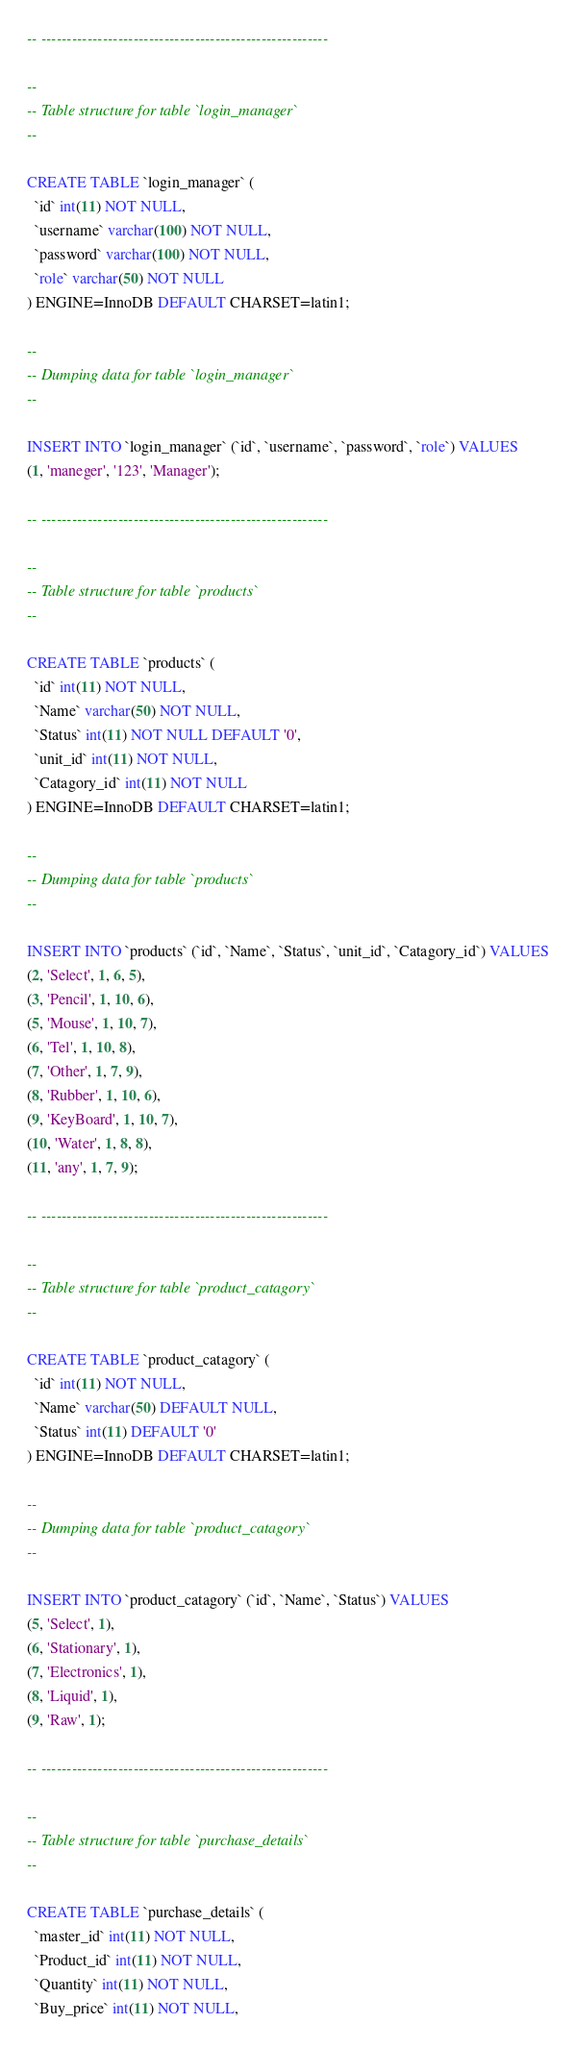<code> <loc_0><loc_0><loc_500><loc_500><_SQL_>-- --------------------------------------------------------

--
-- Table structure for table `login_manager`
--

CREATE TABLE `login_manager` (
  `id` int(11) NOT NULL,
  `username` varchar(100) NOT NULL,
  `password` varchar(100) NOT NULL,
  `role` varchar(50) NOT NULL
) ENGINE=InnoDB DEFAULT CHARSET=latin1;

--
-- Dumping data for table `login_manager`
--

INSERT INTO `login_manager` (`id`, `username`, `password`, `role`) VALUES
(1, 'maneger', '123', 'Manager');

-- --------------------------------------------------------

--
-- Table structure for table `products`
--

CREATE TABLE `products` (
  `id` int(11) NOT NULL,
  `Name` varchar(50) NOT NULL,
  `Status` int(11) NOT NULL DEFAULT '0',
  `unit_id` int(11) NOT NULL,
  `Catagory_id` int(11) NOT NULL
) ENGINE=InnoDB DEFAULT CHARSET=latin1;

--
-- Dumping data for table `products`
--

INSERT INTO `products` (`id`, `Name`, `Status`, `unit_id`, `Catagory_id`) VALUES
(2, 'Select', 1, 6, 5),
(3, 'Pencil', 1, 10, 6),
(5, 'Mouse', 1, 10, 7),
(6, 'Tel', 1, 10, 8),
(7, 'Other', 1, 7, 9),
(8, 'Rubber', 1, 10, 6),
(9, 'KeyBoard', 1, 10, 7),
(10, 'Water', 1, 8, 8),
(11, 'any', 1, 7, 9);

-- --------------------------------------------------------

--
-- Table structure for table `product_catagory`
--

CREATE TABLE `product_catagory` (
  `id` int(11) NOT NULL,
  `Name` varchar(50) DEFAULT NULL,
  `Status` int(11) DEFAULT '0'
) ENGINE=InnoDB DEFAULT CHARSET=latin1;

--
-- Dumping data for table `product_catagory`
--

INSERT INTO `product_catagory` (`id`, `Name`, `Status`) VALUES
(5, 'Select', 1),
(6, 'Stationary', 1),
(7, 'Electronics', 1),
(8, 'Liquid', 1),
(9, 'Raw', 1);

-- --------------------------------------------------------

--
-- Table structure for table `purchase_details`
--

CREATE TABLE `purchase_details` (
  `master_id` int(11) NOT NULL,
  `Product_id` int(11) NOT NULL,
  `Quantity` int(11) NOT NULL,
  `Buy_price` int(11) NOT NULL,</code> 